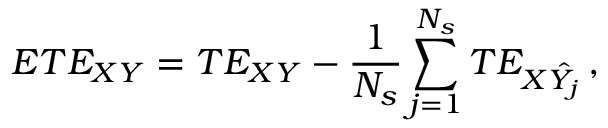<formula> <loc_0><loc_0><loc_500><loc_500>E T E _ { X Y } = T E _ { X Y } - \frac { 1 } { N _ { s } } \sum _ { j = 1 } ^ { N _ { s } } T E _ { X \hat { Y _ { j } } } \, ,</formula> 